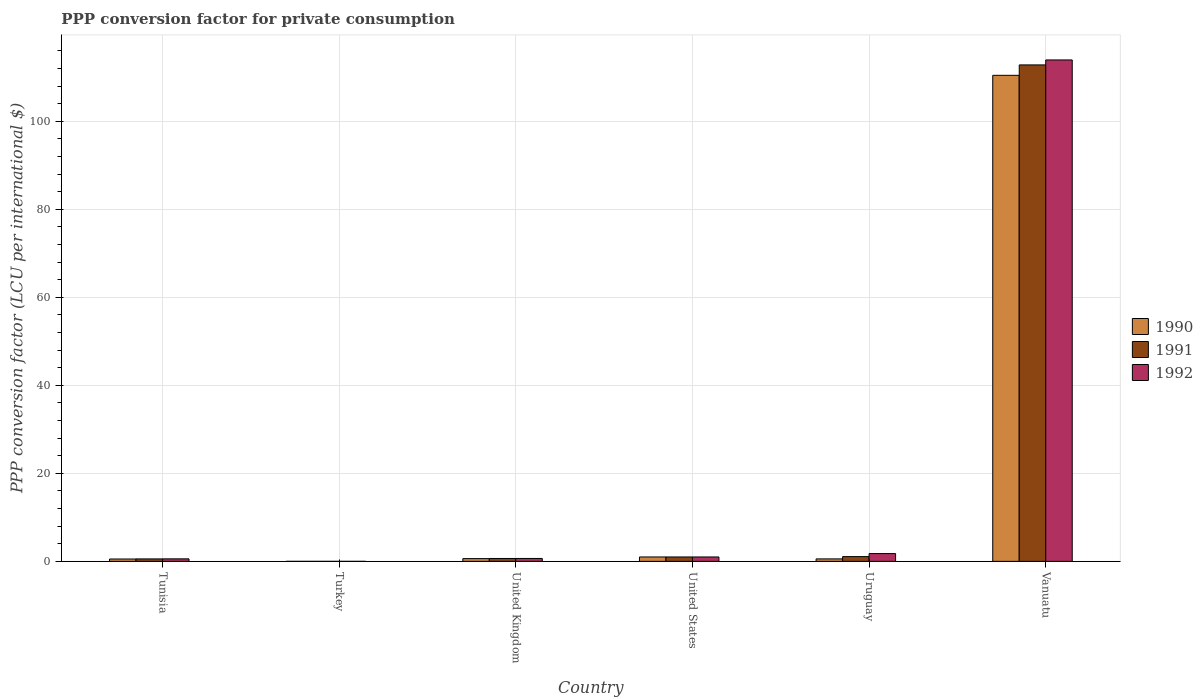Are the number of bars on each tick of the X-axis equal?
Provide a succinct answer. Yes. What is the PPP conversion factor for private consumption in 1990 in United States?
Your response must be concise. 1. Across all countries, what is the maximum PPP conversion factor for private consumption in 1991?
Provide a short and direct response. 112.81. Across all countries, what is the minimum PPP conversion factor for private consumption in 1991?
Your response must be concise. 0. In which country was the PPP conversion factor for private consumption in 1990 maximum?
Make the answer very short. Vanuatu. What is the total PPP conversion factor for private consumption in 1992 in the graph?
Keep it short and to the point. 117.95. What is the difference between the PPP conversion factor for private consumption in 1991 in United Kingdom and that in Uruguay?
Your answer should be compact. -0.43. What is the difference between the PPP conversion factor for private consumption in 1991 in Uruguay and the PPP conversion factor for private consumption in 1992 in Vanuatu?
Ensure brevity in your answer.  -112.86. What is the average PPP conversion factor for private consumption in 1991 per country?
Provide a short and direct response. 19.35. What is the ratio of the PPP conversion factor for private consumption in 1992 in Turkey to that in Uruguay?
Your response must be concise. 0. Is the difference between the PPP conversion factor for private consumption in 1991 in Tunisia and Turkey greater than the difference between the PPP conversion factor for private consumption in 1992 in Tunisia and Turkey?
Your answer should be compact. No. What is the difference between the highest and the second highest PPP conversion factor for private consumption in 1990?
Your answer should be compact. -0.38. What is the difference between the highest and the lowest PPP conversion factor for private consumption in 1992?
Make the answer very short. 113.94. What does the 1st bar from the right in Turkey represents?
Your answer should be compact. 1992. Are all the bars in the graph horizontal?
Your answer should be very brief. No. Are the values on the major ticks of Y-axis written in scientific E-notation?
Provide a succinct answer. No. Does the graph contain grids?
Give a very brief answer. Yes. Where does the legend appear in the graph?
Your answer should be very brief. Center right. How many legend labels are there?
Make the answer very short. 3. How are the legend labels stacked?
Your answer should be compact. Vertical. What is the title of the graph?
Offer a very short reply. PPP conversion factor for private consumption. What is the label or title of the Y-axis?
Your answer should be very brief. PPP conversion factor (LCU per international $). What is the PPP conversion factor (LCU per international $) in 1990 in Tunisia?
Give a very brief answer. 0.53. What is the PPP conversion factor (LCU per international $) in 1991 in Tunisia?
Make the answer very short. 0.56. What is the PPP conversion factor (LCU per international $) in 1992 in Tunisia?
Provide a succinct answer. 0.57. What is the PPP conversion factor (LCU per international $) in 1990 in Turkey?
Your answer should be very brief. 0. What is the PPP conversion factor (LCU per international $) in 1991 in Turkey?
Your answer should be compact. 0. What is the PPP conversion factor (LCU per international $) in 1992 in Turkey?
Your answer should be compact. 0. What is the PPP conversion factor (LCU per international $) of 1990 in United Kingdom?
Provide a succinct answer. 0.62. What is the PPP conversion factor (LCU per international $) of 1991 in United Kingdom?
Your response must be concise. 0.65. What is the PPP conversion factor (LCU per international $) in 1992 in United Kingdom?
Your answer should be compact. 0.66. What is the PPP conversion factor (LCU per international $) in 1991 in United States?
Your answer should be compact. 1. What is the PPP conversion factor (LCU per international $) of 1990 in Uruguay?
Offer a very short reply. 0.56. What is the PPP conversion factor (LCU per international $) in 1991 in Uruguay?
Make the answer very short. 1.08. What is the PPP conversion factor (LCU per international $) in 1992 in Uruguay?
Your answer should be compact. 1.77. What is the PPP conversion factor (LCU per international $) in 1990 in Vanuatu?
Your answer should be very brief. 110.45. What is the PPP conversion factor (LCU per international $) in 1991 in Vanuatu?
Your response must be concise. 112.81. What is the PPP conversion factor (LCU per international $) of 1992 in Vanuatu?
Give a very brief answer. 113.94. Across all countries, what is the maximum PPP conversion factor (LCU per international $) in 1990?
Keep it short and to the point. 110.45. Across all countries, what is the maximum PPP conversion factor (LCU per international $) in 1991?
Give a very brief answer. 112.81. Across all countries, what is the maximum PPP conversion factor (LCU per international $) in 1992?
Offer a very short reply. 113.94. Across all countries, what is the minimum PPP conversion factor (LCU per international $) in 1990?
Keep it short and to the point. 0. Across all countries, what is the minimum PPP conversion factor (LCU per international $) of 1991?
Give a very brief answer. 0. Across all countries, what is the minimum PPP conversion factor (LCU per international $) of 1992?
Provide a succinct answer. 0. What is the total PPP conversion factor (LCU per international $) in 1990 in the graph?
Offer a terse response. 113.17. What is the total PPP conversion factor (LCU per international $) in 1991 in the graph?
Give a very brief answer. 116.11. What is the total PPP conversion factor (LCU per international $) in 1992 in the graph?
Provide a short and direct response. 117.95. What is the difference between the PPP conversion factor (LCU per international $) in 1990 in Tunisia and that in Turkey?
Keep it short and to the point. 0.53. What is the difference between the PPP conversion factor (LCU per international $) of 1991 in Tunisia and that in Turkey?
Ensure brevity in your answer.  0.55. What is the difference between the PPP conversion factor (LCU per international $) of 1992 in Tunisia and that in Turkey?
Make the answer very short. 0.57. What is the difference between the PPP conversion factor (LCU per international $) in 1990 in Tunisia and that in United Kingdom?
Offer a very short reply. -0.09. What is the difference between the PPP conversion factor (LCU per international $) in 1991 in Tunisia and that in United Kingdom?
Provide a succinct answer. -0.1. What is the difference between the PPP conversion factor (LCU per international $) of 1992 in Tunisia and that in United Kingdom?
Your answer should be compact. -0.09. What is the difference between the PPP conversion factor (LCU per international $) of 1990 in Tunisia and that in United States?
Provide a succinct answer. -0.47. What is the difference between the PPP conversion factor (LCU per international $) in 1991 in Tunisia and that in United States?
Keep it short and to the point. -0.44. What is the difference between the PPP conversion factor (LCU per international $) in 1992 in Tunisia and that in United States?
Provide a succinct answer. -0.43. What is the difference between the PPP conversion factor (LCU per international $) of 1990 in Tunisia and that in Uruguay?
Offer a terse response. -0.02. What is the difference between the PPP conversion factor (LCU per international $) of 1991 in Tunisia and that in Uruguay?
Provide a succinct answer. -0.53. What is the difference between the PPP conversion factor (LCU per international $) of 1992 in Tunisia and that in Uruguay?
Make the answer very short. -1.2. What is the difference between the PPP conversion factor (LCU per international $) in 1990 in Tunisia and that in Vanuatu?
Provide a short and direct response. -109.91. What is the difference between the PPP conversion factor (LCU per international $) in 1991 in Tunisia and that in Vanuatu?
Offer a very short reply. -112.26. What is the difference between the PPP conversion factor (LCU per international $) of 1992 in Tunisia and that in Vanuatu?
Make the answer very short. -113.37. What is the difference between the PPP conversion factor (LCU per international $) of 1990 in Turkey and that in United Kingdom?
Give a very brief answer. -0.62. What is the difference between the PPP conversion factor (LCU per international $) of 1991 in Turkey and that in United Kingdom?
Your response must be concise. -0.65. What is the difference between the PPP conversion factor (LCU per international $) in 1992 in Turkey and that in United Kingdom?
Provide a short and direct response. -0.66. What is the difference between the PPP conversion factor (LCU per international $) of 1990 in Turkey and that in United States?
Offer a very short reply. -1. What is the difference between the PPP conversion factor (LCU per international $) of 1991 in Turkey and that in United States?
Provide a short and direct response. -1. What is the difference between the PPP conversion factor (LCU per international $) in 1992 in Turkey and that in United States?
Give a very brief answer. -1. What is the difference between the PPP conversion factor (LCU per international $) of 1990 in Turkey and that in Uruguay?
Give a very brief answer. -0.56. What is the difference between the PPP conversion factor (LCU per international $) of 1991 in Turkey and that in Uruguay?
Make the answer very short. -1.08. What is the difference between the PPP conversion factor (LCU per international $) of 1992 in Turkey and that in Uruguay?
Provide a short and direct response. -1.76. What is the difference between the PPP conversion factor (LCU per international $) of 1990 in Turkey and that in Vanuatu?
Keep it short and to the point. -110.45. What is the difference between the PPP conversion factor (LCU per international $) of 1991 in Turkey and that in Vanuatu?
Make the answer very short. -112.81. What is the difference between the PPP conversion factor (LCU per international $) in 1992 in Turkey and that in Vanuatu?
Offer a very short reply. -113.94. What is the difference between the PPP conversion factor (LCU per international $) of 1990 in United Kingdom and that in United States?
Offer a terse response. -0.38. What is the difference between the PPP conversion factor (LCU per international $) of 1991 in United Kingdom and that in United States?
Offer a very short reply. -0.35. What is the difference between the PPP conversion factor (LCU per international $) of 1992 in United Kingdom and that in United States?
Give a very brief answer. -0.34. What is the difference between the PPP conversion factor (LCU per international $) in 1990 in United Kingdom and that in Uruguay?
Ensure brevity in your answer.  0.06. What is the difference between the PPP conversion factor (LCU per international $) of 1991 in United Kingdom and that in Uruguay?
Your answer should be compact. -0.43. What is the difference between the PPP conversion factor (LCU per international $) of 1992 in United Kingdom and that in Uruguay?
Your answer should be very brief. -1.11. What is the difference between the PPP conversion factor (LCU per international $) of 1990 in United Kingdom and that in Vanuatu?
Offer a very short reply. -109.82. What is the difference between the PPP conversion factor (LCU per international $) in 1991 in United Kingdom and that in Vanuatu?
Ensure brevity in your answer.  -112.16. What is the difference between the PPP conversion factor (LCU per international $) of 1992 in United Kingdom and that in Vanuatu?
Your answer should be very brief. -113.28. What is the difference between the PPP conversion factor (LCU per international $) in 1990 in United States and that in Uruguay?
Keep it short and to the point. 0.44. What is the difference between the PPP conversion factor (LCU per international $) in 1991 in United States and that in Uruguay?
Make the answer very short. -0.08. What is the difference between the PPP conversion factor (LCU per international $) of 1992 in United States and that in Uruguay?
Give a very brief answer. -0.77. What is the difference between the PPP conversion factor (LCU per international $) in 1990 in United States and that in Vanuatu?
Keep it short and to the point. -109.45. What is the difference between the PPP conversion factor (LCU per international $) of 1991 in United States and that in Vanuatu?
Keep it short and to the point. -111.81. What is the difference between the PPP conversion factor (LCU per international $) in 1992 in United States and that in Vanuatu?
Keep it short and to the point. -112.94. What is the difference between the PPP conversion factor (LCU per international $) of 1990 in Uruguay and that in Vanuatu?
Keep it short and to the point. -109.89. What is the difference between the PPP conversion factor (LCU per international $) in 1991 in Uruguay and that in Vanuatu?
Offer a very short reply. -111.73. What is the difference between the PPP conversion factor (LCU per international $) in 1992 in Uruguay and that in Vanuatu?
Make the answer very short. -112.17. What is the difference between the PPP conversion factor (LCU per international $) in 1990 in Tunisia and the PPP conversion factor (LCU per international $) in 1991 in Turkey?
Give a very brief answer. 0.53. What is the difference between the PPP conversion factor (LCU per international $) in 1990 in Tunisia and the PPP conversion factor (LCU per international $) in 1992 in Turkey?
Your response must be concise. 0.53. What is the difference between the PPP conversion factor (LCU per international $) of 1991 in Tunisia and the PPP conversion factor (LCU per international $) of 1992 in Turkey?
Give a very brief answer. 0.55. What is the difference between the PPP conversion factor (LCU per international $) of 1990 in Tunisia and the PPP conversion factor (LCU per international $) of 1991 in United Kingdom?
Ensure brevity in your answer.  -0.12. What is the difference between the PPP conversion factor (LCU per international $) of 1990 in Tunisia and the PPP conversion factor (LCU per international $) of 1992 in United Kingdom?
Make the answer very short. -0.13. What is the difference between the PPP conversion factor (LCU per international $) of 1991 in Tunisia and the PPP conversion factor (LCU per international $) of 1992 in United Kingdom?
Make the answer very short. -0.11. What is the difference between the PPP conversion factor (LCU per international $) in 1990 in Tunisia and the PPP conversion factor (LCU per international $) in 1991 in United States?
Give a very brief answer. -0.47. What is the difference between the PPP conversion factor (LCU per international $) of 1990 in Tunisia and the PPP conversion factor (LCU per international $) of 1992 in United States?
Your answer should be compact. -0.47. What is the difference between the PPP conversion factor (LCU per international $) in 1991 in Tunisia and the PPP conversion factor (LCU per international $) in 1992 in United States?
Your response must be concise. -0.44. What is the difference between the PPP conversion factor (LCU per international $) in 1990 in Tunisia and the PPP conversion factor (LCU per international $) in 1991 in Uruguay?
Offer a very short reply. -0.55. What is the difference between the PPP conversion factor (LCU per international $) of 1990 in Tunisia and the PPP conversion factor (LCU per international $) of 1992 in Uruguay?
Your answer should be compact. -1.23. What is the difference between the PPP conversion factor (LCU per international $) in 1991 in Tunisia and the PPP conversion factor (LCU per international $) in 1992 in Uruguay?
Offer a terse response. -1.21. What is the difference between the PPP conversion factor (LCU per international $) in 1990 in Tunisia and the PPP conversion factor (LCU per international $) in 1991 in Vanuatu?
Offer a very short reply. -112.28. What is the difference between the PPP conversion factor (LCU per international $) in 1990 in Tunisia and the PPP conversion factor (LCU per international $) in 1992 in Vanuatu?
Your answer should be very brief. -113.41. What is the difference between the PPP conversion factor (LCU per international $) of 1991 in Tunisia and the PPP conversion factor (LCU per international $) of 1992 in Vanuatu?
Provide a succinct answer. -113.39. What is the difference between the PPP conversion factor (LCU per international $) in 1990 in Turkey and the PPP conversion factor (LCU per international $) in 1991 in United Kingdom?
Provide a succinct answer. -0.65. What is the difference between the PPP conversion factor (LCU per international $) of 1990 in Turkey and the PPP conversion factor (LCU per international $) of 1992 in United Kingdom?
Make the answer very short. -0.66. What is the difference between the PPP conversion factor (LCU per international $) of 1991 in Turkey and the PPP conversion factor (LCU per international $) of 1992 in United Kingdom?
Your response must be concise. -0.66. What is the difference between the PPP conversion factor (LCU per international $) in 1990 in Turkey and the PPP conversion factor (LCU per international $) in 1991 in United States?
Keep it short and to the point. -1. What is the difference between the PPP conversion factor (LCU per international $) of 1990 in Turkey and the PPP conversion factor (LCU per international $) of 1992 in United States?
Offer a terse response. -1. What is the difference between the PPP conversion factor (LCU per international $) in 1991 in Turkey and the PPP conversion factor (LCU per international $) in 1992 in United States?
Ensure brevity in your answer.  -1. What is the difference between the PPP conversion factor (LCU per international $) in 1990 in Turkey and the PPP conversion factor (LCU per international $) in 1991 in Uruguay?
Your answer should be compact. -1.08. What is the difference between the PPP conversion factor (LCU per international $) of 1990 in Turkey and the PPP conversion factor (LCU per international $) of 1992 in Uruguay?
Keep it short and to the point. -1.77. What is the difference between the PPP conversion factor (LCU per international $) in 1991 in Turkey and the PPP conversion factor (LCU per international $) in 1992 in Uruguay?
Offer a terse response. -1.77. What is the difference between the PPP conversion factor (LCU per international $) of 1990 in Turkey and the PPP conversion factor (LCU per international $) of 1991 in Vanuatu?
Give a very brief answer. -112.81. What is the difference between the PPP conversion factor (LCU per international $) in 1990 in Turkey and the PPP conversion factor (LCU per international $) in 1992 in Vanuatu?
Ensure brevity in your answer.  -113.94. What is the difference between the PPP conversion factor (LCU per international $) in 1991 in Turkey and the PPP conversion factor (LCU per international $) in 1992 in Vanuatu?
Keep it short and to the point. -113.94. What is the difference between the PPP conversion factor (LCU per international $) in 1990 in United Kingdom and the PPP conversion factor (LCU per international $) in 1991 in United States?
Your response must be concise. -0.38. What is the difference between the PPP conversion factor (LCU per international $) in 1990 in United Kingdom and the PPP conversion factor (LCU per international $) in 1992 in United States?
Keep it short and to the point. -0.38. What is the difference between the PPP conversion factor (LCU per international $) in 1991 in United Kingdom and the PPP conversion factor (LCU per international $) in 1992 in United States?
Give a very brief answer. -0.35. What is the difference between the PPP conversion factor (LCU per international $) in 1990 in United Kingdom and the PPP conversion factor (LCU per international $) in 1991 in Uruguay?
Your response must be concise. -0.46. What is the difference between the PPP conversion factor (LCU per international $) of 1990 in United Kingdom and the PPP conversion factor (LCU per international $) of 1992 in Uruguay?
Your answer should be compact. -1.15. What is the difference between the PPP conversion factor (LCU per international $) of 1991 in United Kingdom and the PPP conversion factor (LCU per international $) of 1992 in Uruguay?
Give a very brief answer. -1.12. What is the difference between the PPP conversion factor (LCU per international $) in 1990 in United Kingdom and the PPP conversion factor (LCU per international $) in 1991 in Vanuatu?
Give a very brief answer. -112.19. What is the difference between the PPP conversion factor (LCU per international $) in 1990 in United Kingdom and the PPP conversion factor (LCU per international $) in 1992 in Vanuatu?
Ensure brevity in your answer.  -113.32. What is the difference between the PPP conversion factor (LCU per international $) in 1991 in United Kingdom and the PPP conversion factor (LCU per international $) in 1992 in Vanuatu?
Provide a short and direct response. -113.29. What is the difference between the PPP conversion factor (LCU per international $) of 1990 in United States and the PPP conversion factor (LCU per international $) of 1991 in Uruguay?
Ensure brevity in your answer.  -0.08. What is the difference between the PPP conversion factor (LCU per international $) of 1990 in United States and the PPP conversion factor (LCU per international $) of 1992 in Uruguay?
Give a very brief answer. -0.77. What is the difference between the PPP conversion factor (LCU per international $) of 1991 in United States and the PPP conversion factor (LCU per international $) of 1992 in Uruguay?
Provide a succinct answer. -0.77. What is the difference between the PPP conversion factor (LCU per international $) in 1990 in United States and the PPP conversion factor (LCU per international $) in 1991 in Vanuatu?
Ensure brevity in your answer.  -111.81. What is the difference between the PPP conversion factor (LCU per international $) of 1990 in United States and the PPP conversion factor (LCU per international $) of 1992 in Vanuatu?
Provide a succinct answer. -112.94. What is the difference between the PPP conversion factor (LCU per international $) of 1991 in United States and the PPP conversion factor (LCU per international $) of 1992 in Vanuatu?
Offer a terse response. -112.94. What is the difference between the PPP conversion factor (LCU per international $) of 1990 in Uruguay and the PPP conversion factor (LCU per international $) of 1991 in Vanuatu?
Provide a succinct answer. -112.26. What is the difference between the PPP conversion factor (LCU per international $) in 1990 in Uruguay and the PPP conversion factor (LCU per international $) in 1992 in Vanuatu?
Offer a terse response. -113.38. What is the difference between the PPP conversion factor (LCU per international $) of 1991 in Uruguay and the PPP conversion factor (LCU per international $) of 1992 in Vanuatu?
Ensure brevity in your answer.  -112.86. What is the average PPP conversion factor (LCU per international $) in 1990 per country?
Give a very brief answer. 18.86. What is the average PPP conversion factor (LCU per international $) in 1991 per country?
Offer a terse response. 19.35. What is the average PPP conversion factor (LCU per international $) in 1992 per country?
Give a very brief answer. 19.66. What is the difference between the PPP conversion factor (LCU per international $) in 1990 and PPP conversion factor (LCU per international $) in 1991 in Tunisia?
Provide a short and direct response. -0.02. What is the difference between the PPP conversion factor (LCU per international $) of 1990 and PPP conversion factor (LCU per international $) of 1992 in Tunisia?
Your response must be concise. -0.04. What is the difference between the PPP conversion factor (LCU per international $) in 1991 and PPP conversion factor (LCU per international $) in 1992 in Tunisia?
Your response must be concise. -0.02. What is the difference between the PPP conversion factor (LCU per international $) in 1990 and PPP conversion factor (LCU per international $) in 1991 in Turkey?
Ensure brevity in your answer.  -0. What is the difference between the PPP conversion factor (LCU per international $) of 1990 and PPP conversion factor (LCU per international $) of 1992 in Turkey?
Make the answer very short. -0. What is the difference between the PPP conversion factor (LCU per international $) in 1991 and PPP conversion factor (LCU per international $) in 1992 in Turkey?
Provide a succinct answer. -0. What is the difference between the PPP conversion factor (LCU per international $) of 1990 and PPP conversion factor (LCU per international $) of 1991 in United Kingdom?
Your response must be concise. -0.03. What is the difference between the PPP conversion factor (LCU per international $) in 1990 and PPP conversion factor (LCU per international $) in 1992 in United Kingdom?
Provide a short and direct response. -0.04. What is the difference between the PPP conversion factor (LCU per international $) in 1991 and PPP conversion factor (LCU per international $) in 1992 in United Kingdom?
Your response must be concise. -0.01. What is the difference between the PPP conversion factor (LCU per international $) of 1990 and PPP conversion factor (LCU per international $) of 1991 in Uruguay?
Your response must be concise. -0.52. What is the difference between the PPP conversion factor (LCU per international $) of 1990 and PPP conversion factor (LCU per international $) of 1992 in Uruguay?
Your answer should be compact. -1.21. What is the difference between the PPP conversion factor (LCU per international $) in 1991 and PPP conversion factor (LCU per international $) in 1992 in Uruguay?
Offer a very short reply. -0.69. What is the difference between the PPP conversion factor (LCU per international $) in 1990 and PPP conversion factor (LCU per international $) in 1991 in Vanuatu?
Your answer should be compact. -2.37. What is the difference between the PPP conversion factor (LCU per international $) in 1990 and PPP conversion factor (LCU per international $) in 1992 in Vanuatu?
Provide a succinct answer. -3.49. What is the difference between the PPP conversion factor (LCU per international $) in 1991 and PPP conversion factor (LCU per international $) in 1992 in Vanuatu?
Give a very brief answer. -1.13. What is the ratio of the PPP conversion factor (LCU per international $) in 1990 in Tunisia to that in Turkey?
Offer a terse response. 312.81. What is the ratio of the PPP conversion factor (LCU per international $) of 1991 in Tunisia to that in Turkey?
Your response must be concise. 208.65. What is the ratio of the PPP conversion factor (LCU per international $) of 1992 in Tunisia to that in Turkey?
Give a very brief answer. 132.9. What is the ratio of the PPP conversion factor (LCU per international $) in 1990 in Tunisia to that in United Kingdom?
Your answer should be very brief. 0.86. What is the ratio of the PPP conversion factor (LCU per international $) of 1991 in Tunisia to that in United Kingdom?
Make the answer very short. 0.85. What is the ratio of the PPP conversion factor (LCU per international $) of 1992 in Tunisia to that in United Kingdom?
Keep it short and to the point. 0.86. What is the ratio of the PPP conversion factor (LCU per international $) in 1990 in Tunisia to that in United States?
Make the answer very short. 0.53. What is the ratio of the PPP conversion factor (LCU per international $) in 1991 in Tunisia to that in United States?
Provide a succinct answer. 0.56. What is the ratio of the PPP conversion factor (LCU per international $) in 1992 in Tunisia to that in United States?
Give a very brief answer. 0.57. What is the ratio of the PPP conversion factor (LCU per international $) in 1990 in Tunisia to that in Uruguay?
Provide a succinct answer. 0.96. What is the ratio of the PPP conversion factor (LCU per international $) of 1991 in Tunisia to that in Uruguay?
Your answer should be very brief. 0.51. What is the ratio of the PPP conversion factor (LCU per international $) of 1992 in Tunisia to that in Uruguay?
Give a very brief answer. 0.32. What is the ratio of the PPP conversion factor (LCU per international $) of 1990 in Tunisia to that in Vanuatu?
Ensure brevity in your answer.  0. What is the ratio of the PPP conversion factor (LCU per international $) of 1991 in Tunisia to that in Vanuatu?
Your answer should be compact. 0. What is the ratio of the PPP conversion factor (LCU per international $) of 1992 in Tunisia to that in Vanuatu?
Offer a very short reply. 0.01. What is the ratio of the PPP conversion factor (LCU per international $) of 1990 in Turkey to that in United Kingdom?
Ensure brevity in your answer.  0. What is the ratio of the PPP conversion factor (LCU per international $) of 1991 in Turkey to that in United Kingdom?
Your answer should be compact. 0. What is the ratio of the PPP conversion factor (LCU per international $) of 1992 in Turkey to that in United Kingdom?
Your answer should be very brief. 0.01. What is the ratio of the PPP conversion factor (LCU per international $) in 1990 in Turkey to that in United States?
Provide a short and direct response. 0. What is the ratio of the PPP conversion factor (LCU per international $) in 1991 in Turkey to that in United States?
Provide a succinct answer. 0. What is the ratio of the PPP conversion factor (LCU per international $) in 1992 in Turkey to that in United States?
Your answer should be compact. 0. What is the ratio of the PPP conversion factor (LCU per international $) of 1990 in Turkey to that in Uruguay?
Your answer should be compact. 0. What is the ratio of the PPP conversion factor (LCU per international $) in 1991 in Turkey to that in Uruguay?
Provide a succinct answer. 0. What is the ratio of the PPP conversion factor (LCU per international $) in 1992 in Turkey to that in Uruguay?
Your response must be concise. 0. What is the ratio of the PPP conversion factor (LCU per international $) in 1991 in Turkey to that in Vanuatu?
Give a very brief answer. 0. What is the ratio of the PPP conversion factor (LCU per international $) of 1992 in Turkey to that in Vanuatu?
Keep it short and to the point. 0. What is the ratio of the PPP conversion factor (LCU per international $) in 1990 in United Kingdom to that in United States?
Offer a terse response. 0.62. What is the ratio of the PPP conversion factor (LCU per international $) of 1991 in United Kingdom to that in United States?
Ensure brevity in your answer.  0.65. What is the ratio of the PPP conversion factor (LCU per international $) in 1992 in United Kingdom to that in United States?
Provide a short and direct response. 0.66. What is the ratio of the PPP conversion factor (LCU per international $) of 1990 in United Kingdom to that in Uruguay?
Provide a succinct answer. 1.12. What is the ratio of the PPP conversion factor (LCU per international $) in 1991 in United Kingdom to that in Uruguay?
Offer a terse response. 0.6. What is the ratio of the PPP conversion factor (LCU per international $) in 1992 in United Kingdom to that in Uruguay?
Provide a short and direct response. 0.37. What is the ratio of the PPP conversion factor (LCU per international $) of 1990 in United Kingdom to that in Vanuatu?
Give a very brief answer. 0.01. What is the ratio of the PPP conversion factor (LCU per international $) of 1991 in United Kingdom to that in Vanuatu?
Provide a succinct answer. 0.01. What is the ratio of the PPP conversion factor (LCU per international $) of 1992 in United Kingdom to that in Vanuatu?
Offer a very short reply. 0.01. What is the ratio of the PPP conversion factor (LCU per international $) of 1990 in United States to that in Uruguay?
Make the answer very short. 1.79. What is the ratio of the PPP conversion factor (LCU per international $) of 1991 in United States to that in Uruguay?
Give a very brief answer. 0.92. What is the ratio of the PPP conversion factor (LCU per international $) of 1992 in United States to that in Uruguay?
Your response must be concise. 0.57. What is the ratio of the PPP conversion factor (LCU per international $) in 1990 in United States to that in Vanuatu?
Keep it short and to the point. 0.01. What is the ratio of the PPP conversion factor (LCU per international $) of 1991 in United States to that in Vanuatu?
Provide a short and direct response. 0.01. What is the ratio of the PPP conversion factor (LCU per international $) in 1992 in United States to that in Vanuatu?
Ensure brevity in your answer.  0.01. What is the ratio of the PPP conversion factor (LCU per international $) of 1990 in Uruguay to that in Vanuatu?
Provide a short and direct response. 0.01. What is the ratio of the PPP conversion factor (LCU per international $) of 1991 in Uruguay to that in Vanuatu?
Ensure brevity in your answer.  0.01. What is the ratio of the PPP conversion factor (LCU per international $) of 1992 in Uruguay to that in Vanuatu?
Offer a very short reply. 0.02. What is the difference between the highest and the second highest PPP conversion factor (LCU per international $) of 1990?
Provide a short and direct response. 109.45. What is the difference between the highest and the second highest PPP conversion factor (LCU per international $) in 1991?
Offer a very short reply. 111.73. What is the difference between the highest and the second highest PPP conversion factor (LCU per international $) of 1992?
Your response must be concise. 112.17. What is the difference between the highest and the lowest PPP conversion factor (LCU per international $) of 1990?
Provide a succinct answer. 110.45. What is the difference between the highest and the lowest PPP conversion factor (LCU per international $) of 1991?
Provide a short and direct response. 112.81. What is the difference between the highest and the lowest PPP conversion factor (LCU per international $) of 1992?
Provide a short and direct response. 113.94. 